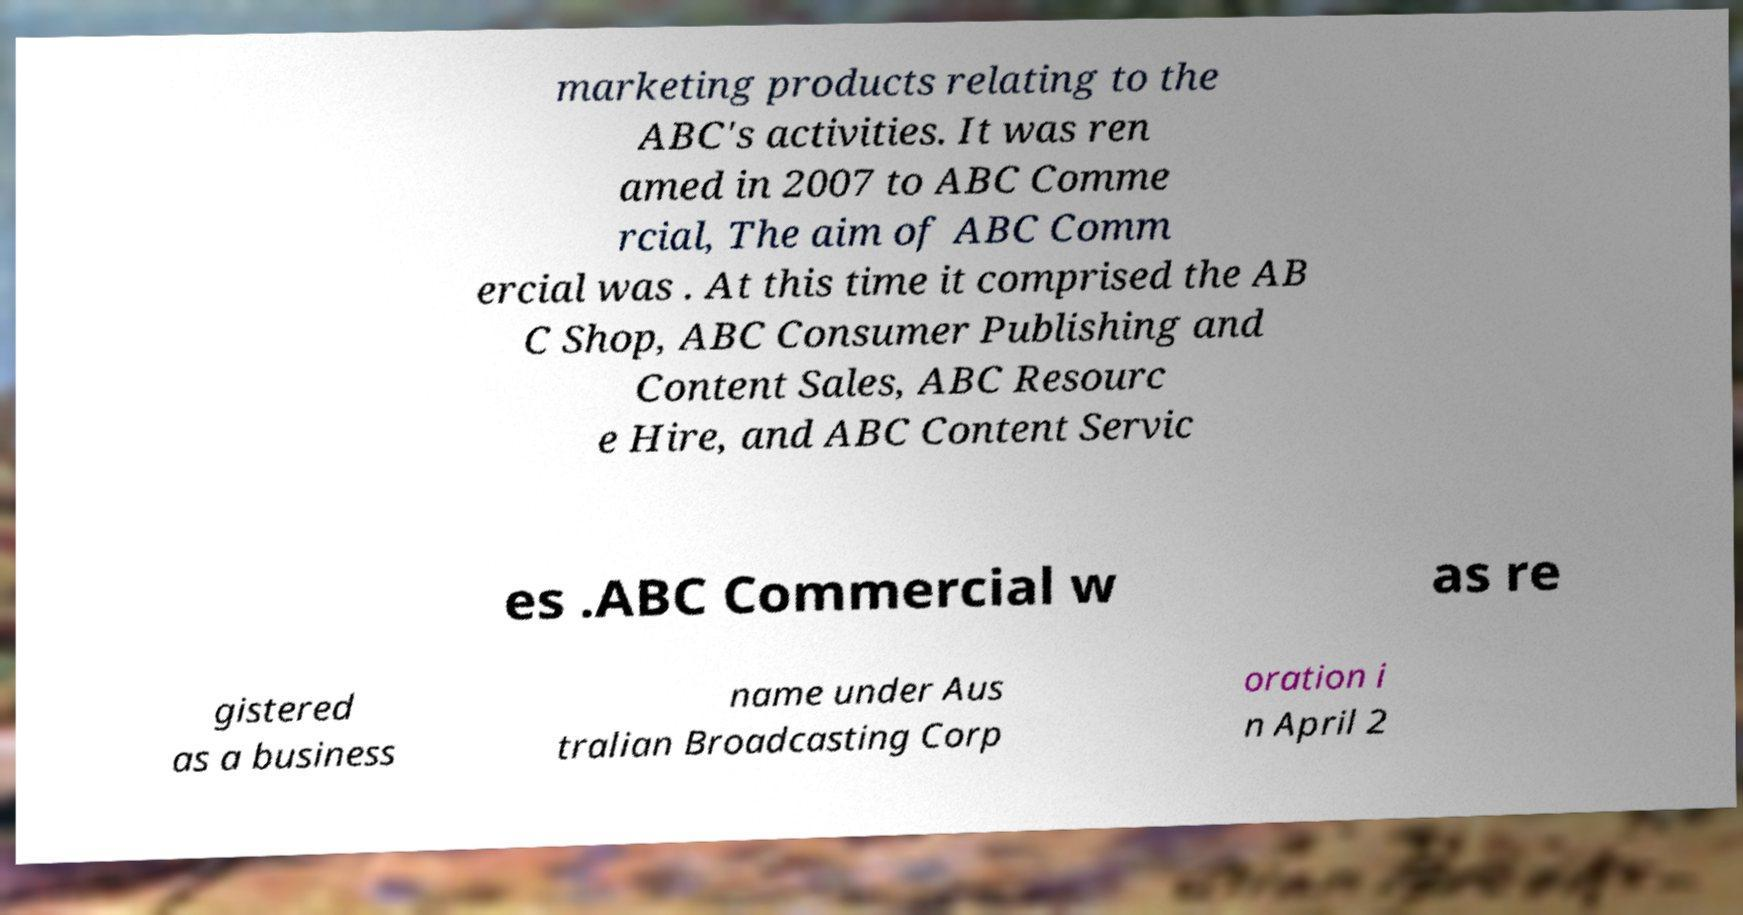There's text embedded in this image that I need extracted. Can you transcribe it verbatim? marketing products relating to the ABC's activities. It was ren amed in 2007 to ABC Comme rcial, The aim of ABC Comm ercial was . At this time it comprised the AB C Shop, ABC Consumer Publishing and Content Sales, ABC Resourc e Hire, and ABC Content Servic es .ABC Commercial w as re gistered as a business name under Aus tralian Broadcasting Corp oration i n April 2 